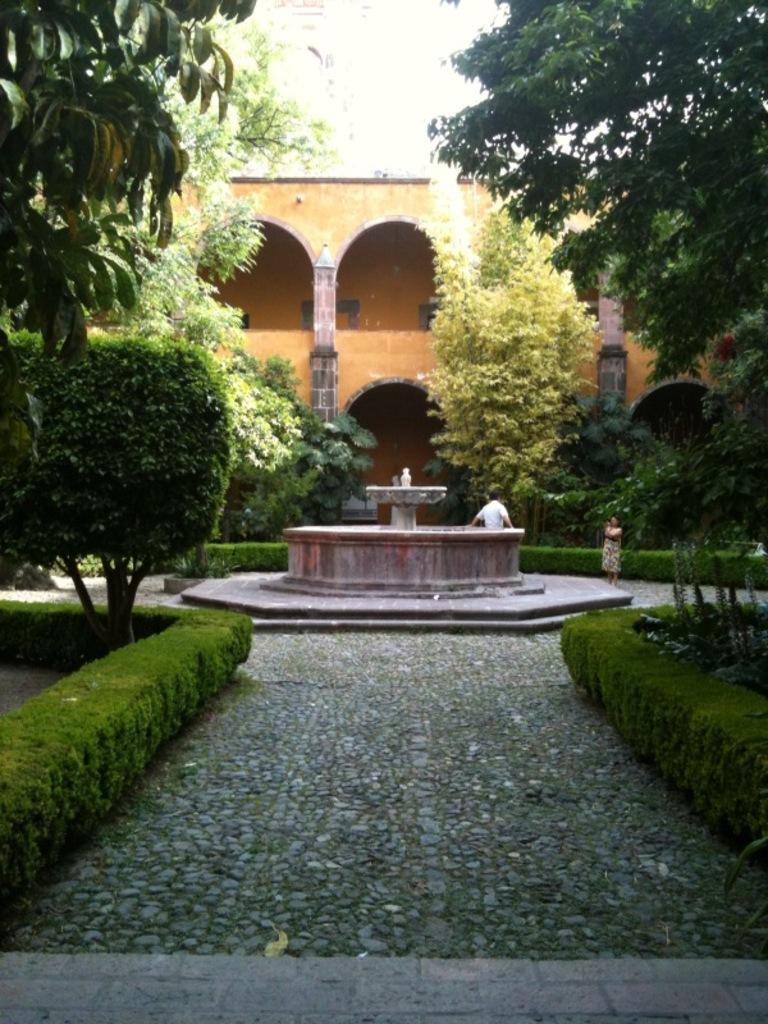How would you summarize this image in a sentence or two? In this picture on both right and left side of the image there are trees. At the center there is a fountain. Beside fountain two people were standing. At the back side there is a building. 